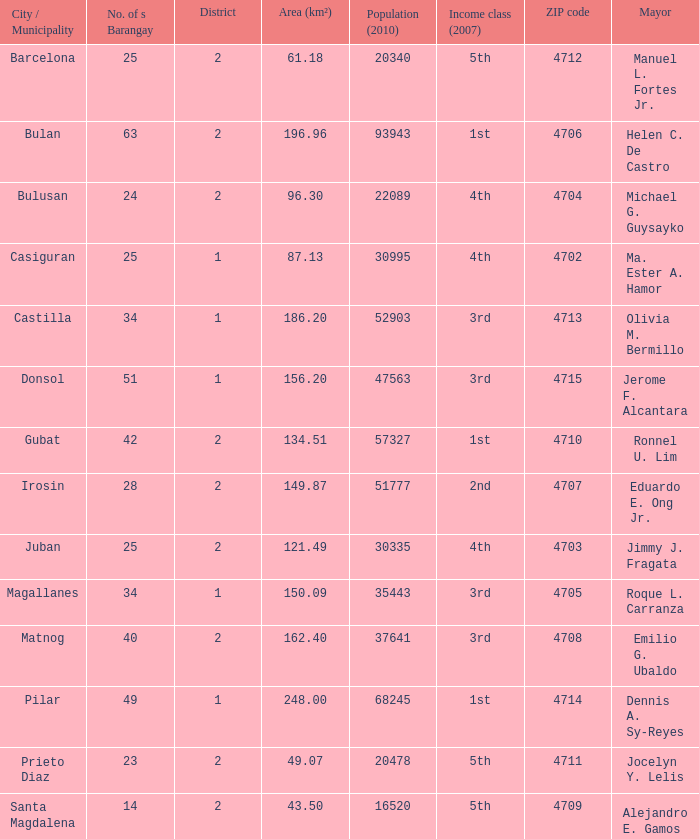51? 1.0. 